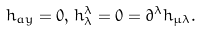Convert formula to latex. <formula><loc_0><loc_0><loc_500><loc_500>h _ { a y } = 0 , \, h _ { \lambda } ^ { \lambda } = 0 = \partial ^ { \lambda } h _ { \mu \lambda } .</formula> 